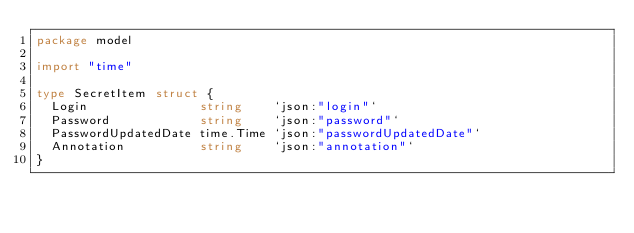<code> <loc_0><loc_0><loc_500><loc_500><_Go_>package model

import "time"

type SecretItem struct {
	Login               string    `json:"login"`
	Password            string    `json:"password"`
	PasswordUpdatedDate time.Time `json:"passwordUpdatedDate"`
	Annotation          string    `json:"annotation"`
}
</code> 